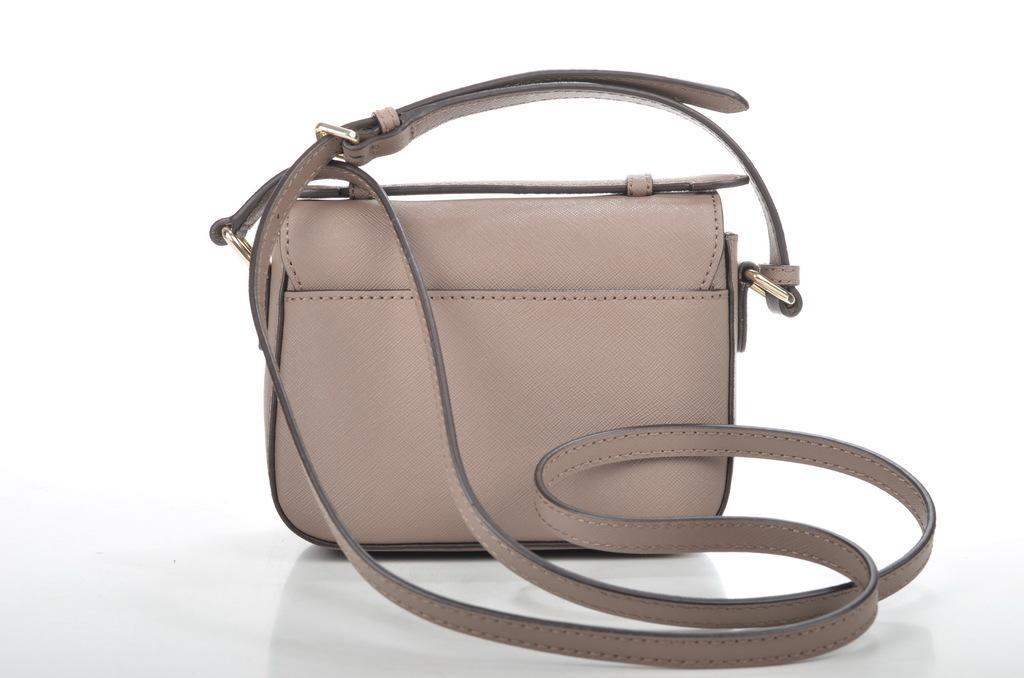What object is present in the image? There is a handbag in the image. What material is used for the handbag? The handbag has leather on it. Is there any accessory or feature related to the handbag? Yes, there is a holder associated with the handbag. What time of day is depicted in the image? The time of day is not mentioned or depicted in the image. What type of list can be seen in the image? There is no list present in the image. 